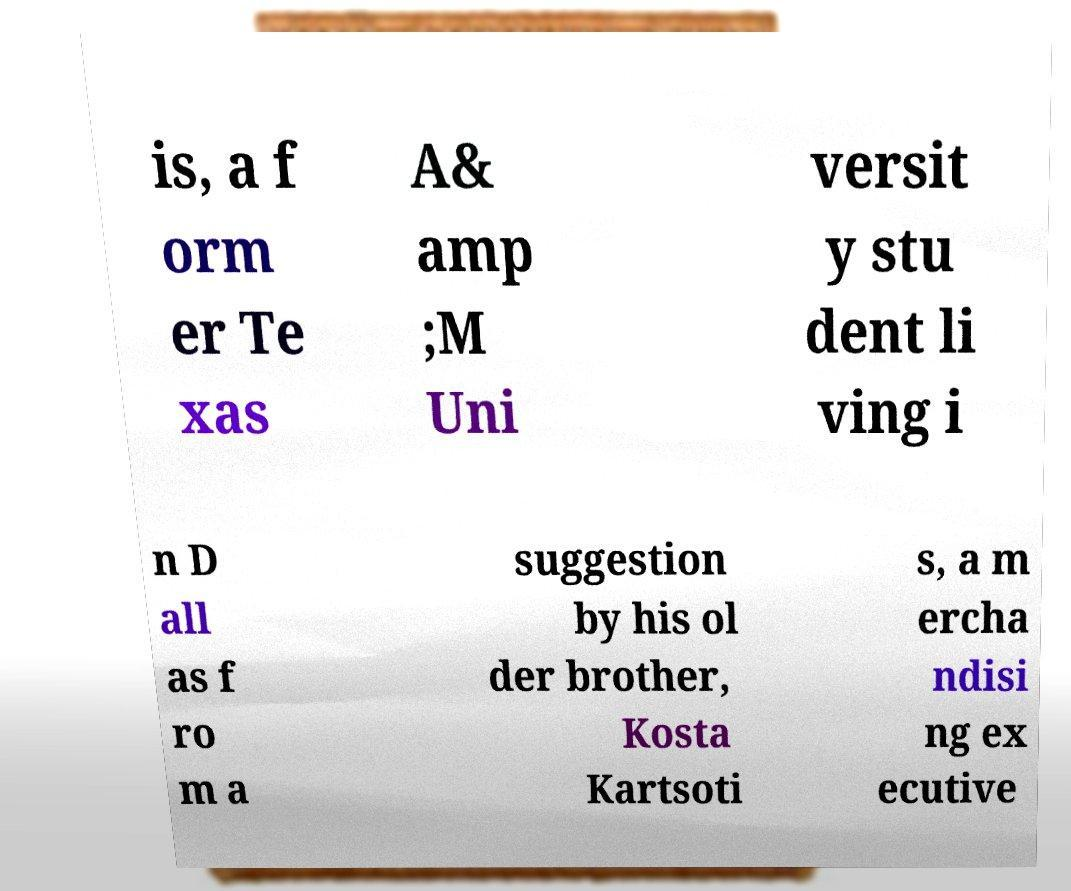There's text embedded in this image that I need extracted. Can you transcribe it verbatim? is, a f orm er Te xas A& amp ;M Uni versit y stu dent li ving i n D all as f ro m a suggestion by his ol der brother, Kosta Kartsoti s, a m ercha ndisi ng ex ecutive 